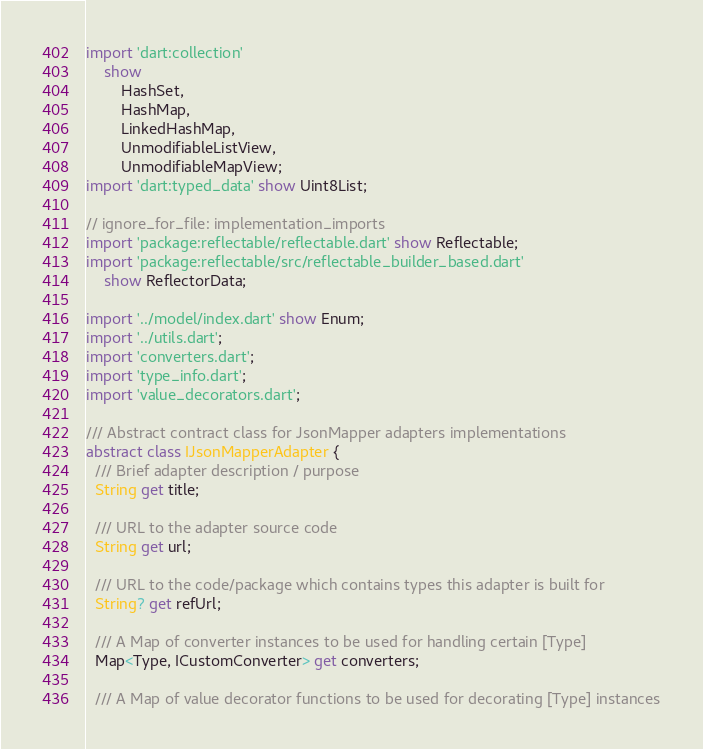Convert code to text. <code><loc_0><loc_0><loc_500><loc_500><_Dart_>import 'dart:collection'
    show
        HashSet,
        HashMap,
        LinkedHashMap,
        UnmodifiableListView,
        UnmodifiableMapView;
import 'dart:typed_data' show Uint8List;

// ignore_for_file: implementation_imports
import 'package:reflectable/reflectable.dart' show Reflectable;
import 'package:reflectable/src/reflectable_builder_based.dart'
    show ReflectorData;

import '../model/index.dart' show Enum;
import '../utils.dart';
import 'converters.dart';
import 'type_info.dart';
import 'value_decorators.dart';

/// Abstract contract class for JsonMapper adapters implementations
abstract class IJsonMapperAdapter {
  /// Brief adapter description / purpose
  String get title;

  /// URL to the adapter source code
  String get url;

  /// URL to the code/package which contains types this adapter is built for
  String? get refUrl;

  /// A Map of converter instances to be used for handling certain [Type]
  Map<Type, ICustomConverter> get converters;

  /// A Map of value decorator functions to be used for decorating [Type] instances</code> 